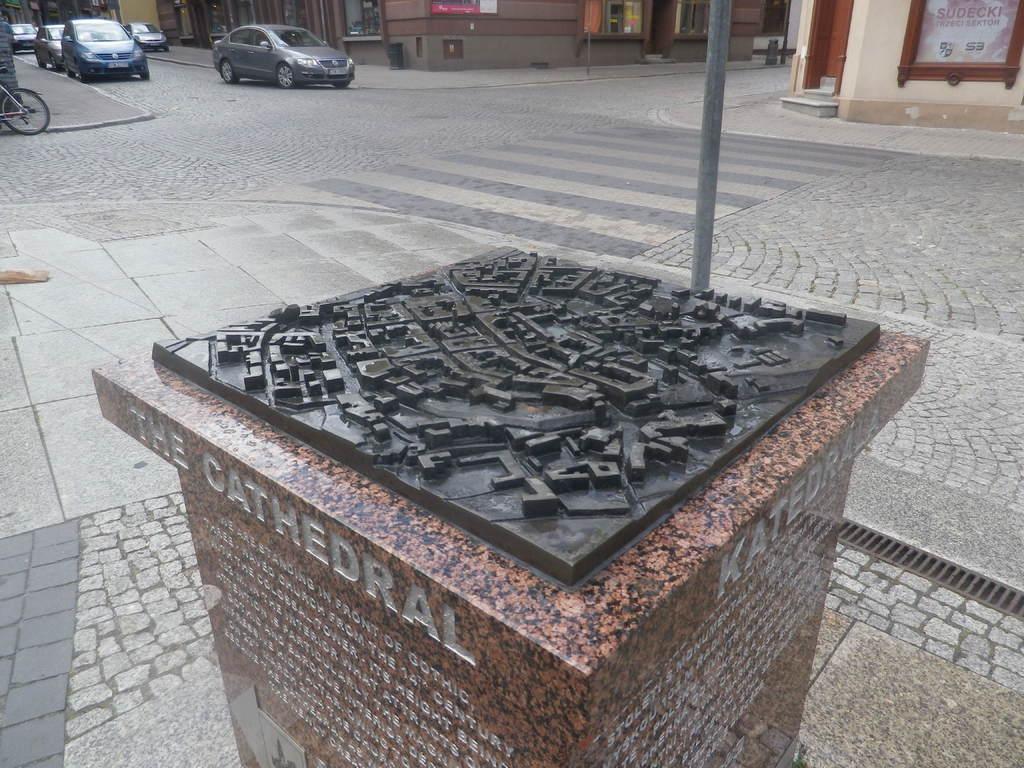Describe this image in one or two sentences. In this image at the bottom there is a memorial, on which there is a text, at the top there is a road, on which there are some vehicles, poles, bicycle, beside the road, I can see the building, wall. 